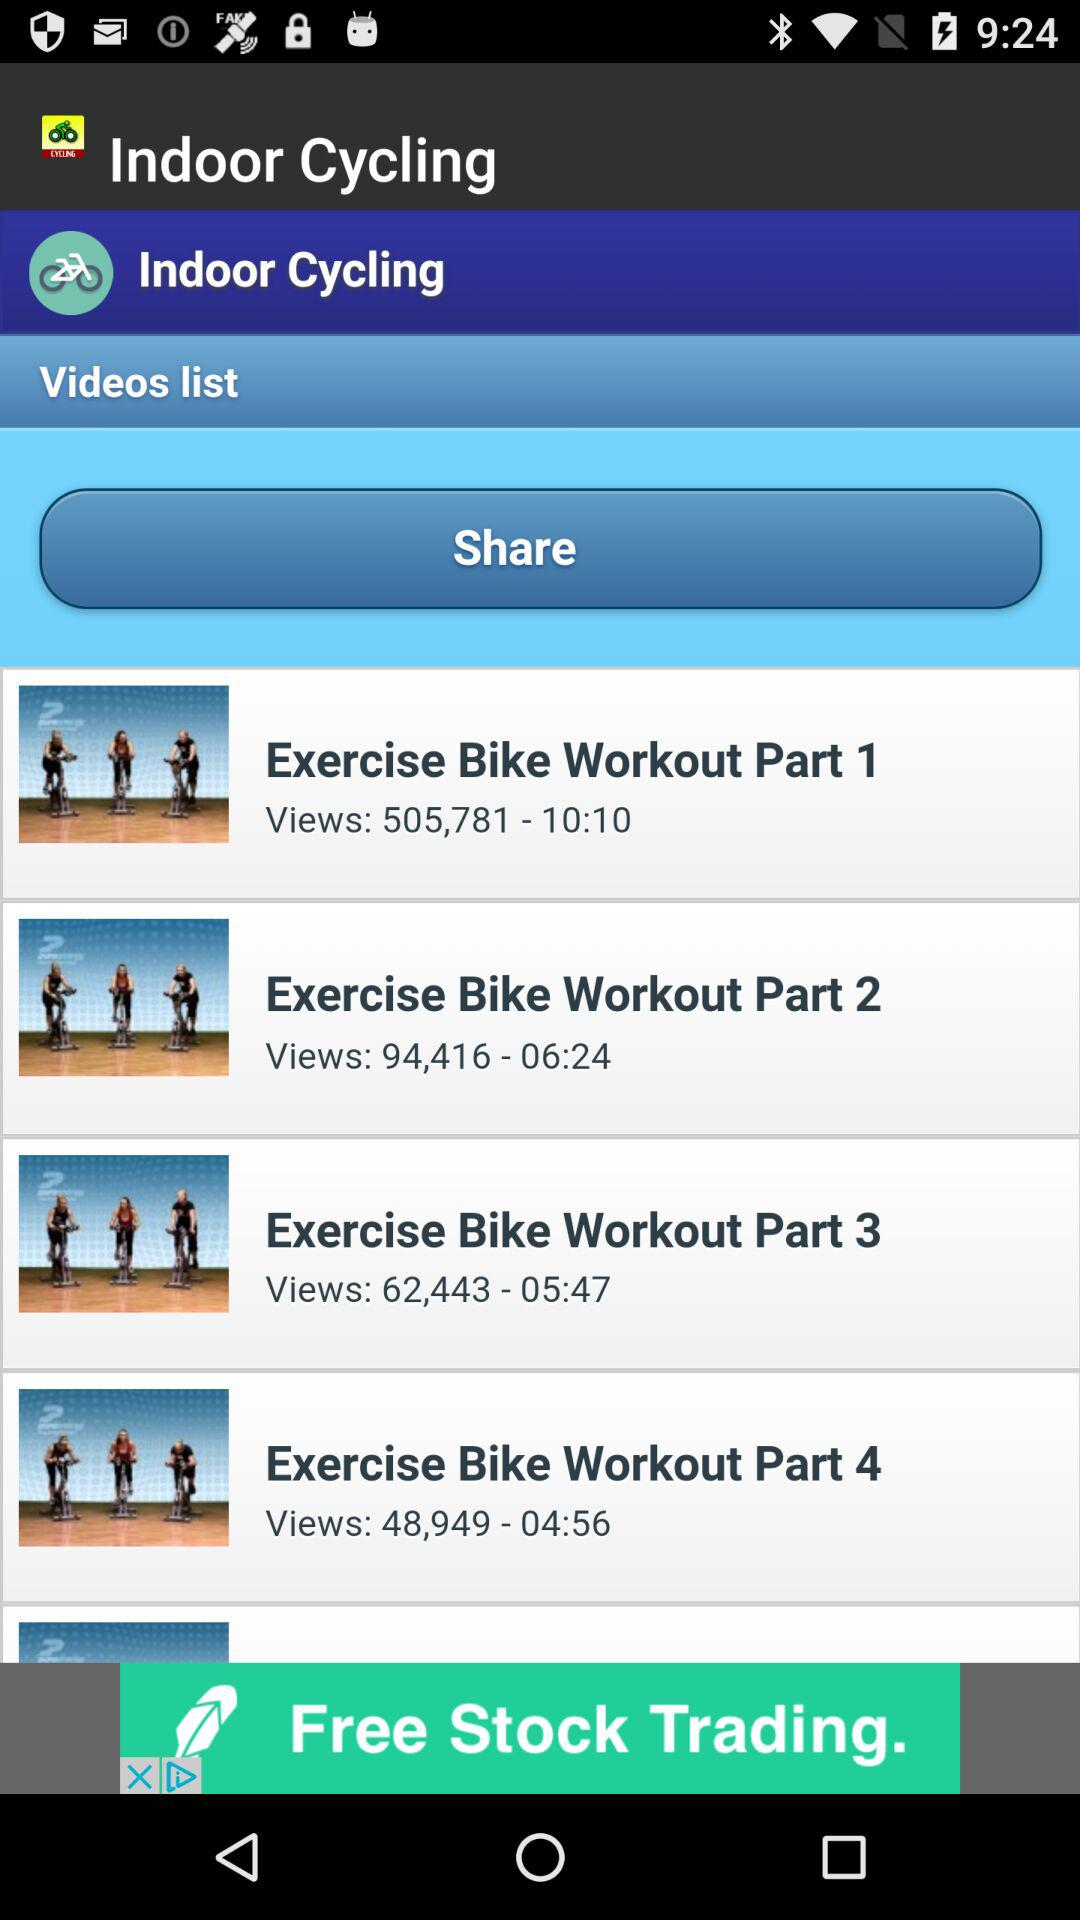How many views did the "Exercise Bike Workout Part 1" video get? The "Exercise Bike Workout Part 1" video got 505,781 views. 